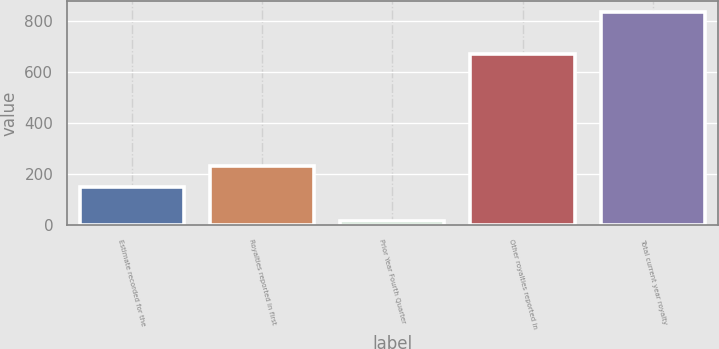Convert chart to OTSL. <chart><loc_0><loc_0><loc_500><loc_500><bar_chart><fcel>Estimate recorded for the<fcel>Royalties reported in first<fcel>Prior Year Fourth Quarter<fcel>Other royalties reported in<fcel>Total current year royalty<nl><fcel>150<fcel>232.1<fcel>17<fcel>670<fcel>838<nl></chart> 